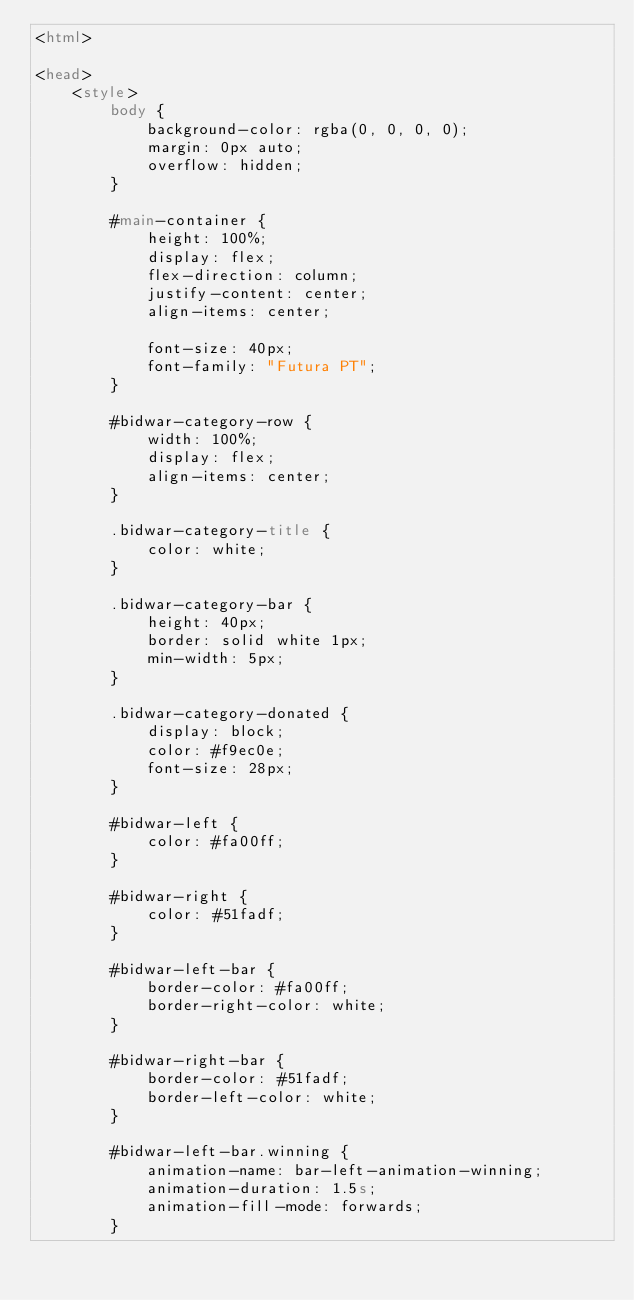<code> <loc_0><loc_0><loc_500><loc_500><_HTML_><html>

<head>
    <style>
        body {
            background-color: rgba(0, 0, 0, 0);
            margin: 0px auto;
            overflow: hidden;
        }

        #main-container {
            height: 100%;
            display: flex;
            flex-direction: column;
            justify-content: center;
            align-items: center;

            font-size: 40px;
            font-family: "Futura PT";
        }

        #bidwar-category-row {
            width: 100%;
            display: flex;
            align-items: center;
        }

        .bidwar-category-title {
            color: white;
        }

        .bidwar-category-bar {
            height: 40px;
            border: solid white 1px;
            min-width: 5px;
        }

        .bidwar-category-donated {
            display: block;
            color: #f9ec0e;
            font-size: 28px;
        }

        #bidwar-left {
            color: #fa00ff;
        }

        #bidwar-right {
            color: #51fadf;
        }

        #bidwar-left-bar {
            border-color: #fa00ff;
            border-right-color: white;
        }

        #bidwar-right-bar {
            border-color: #51fadf;
            border-left-color: white;
        }

        #bidwar-left-bar.winning {
            animation-name: bar-left-animation-winning;
            animation-duration: 1.5s;
            animation-fill-mode: forwards;
        }
</code> 